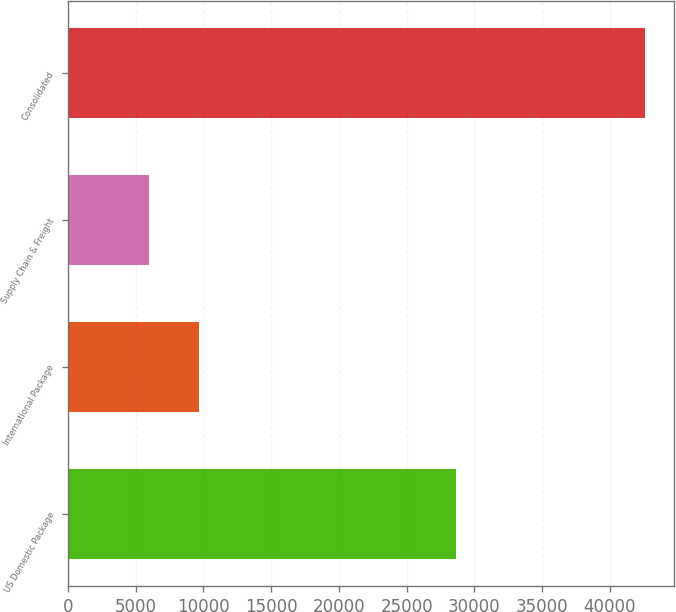Convert chart to OTSL. <chart><loc_0><loc_0><loc_500><loc_500><bar_chart><fcel>US Domestic Package<fcel>International Package<fcel>Supply Chain & Freight<fcel>Consolidated<nl><fcel>28610<fcel>9652.7<fcel>5994<fcel>42581<nl></chart> 